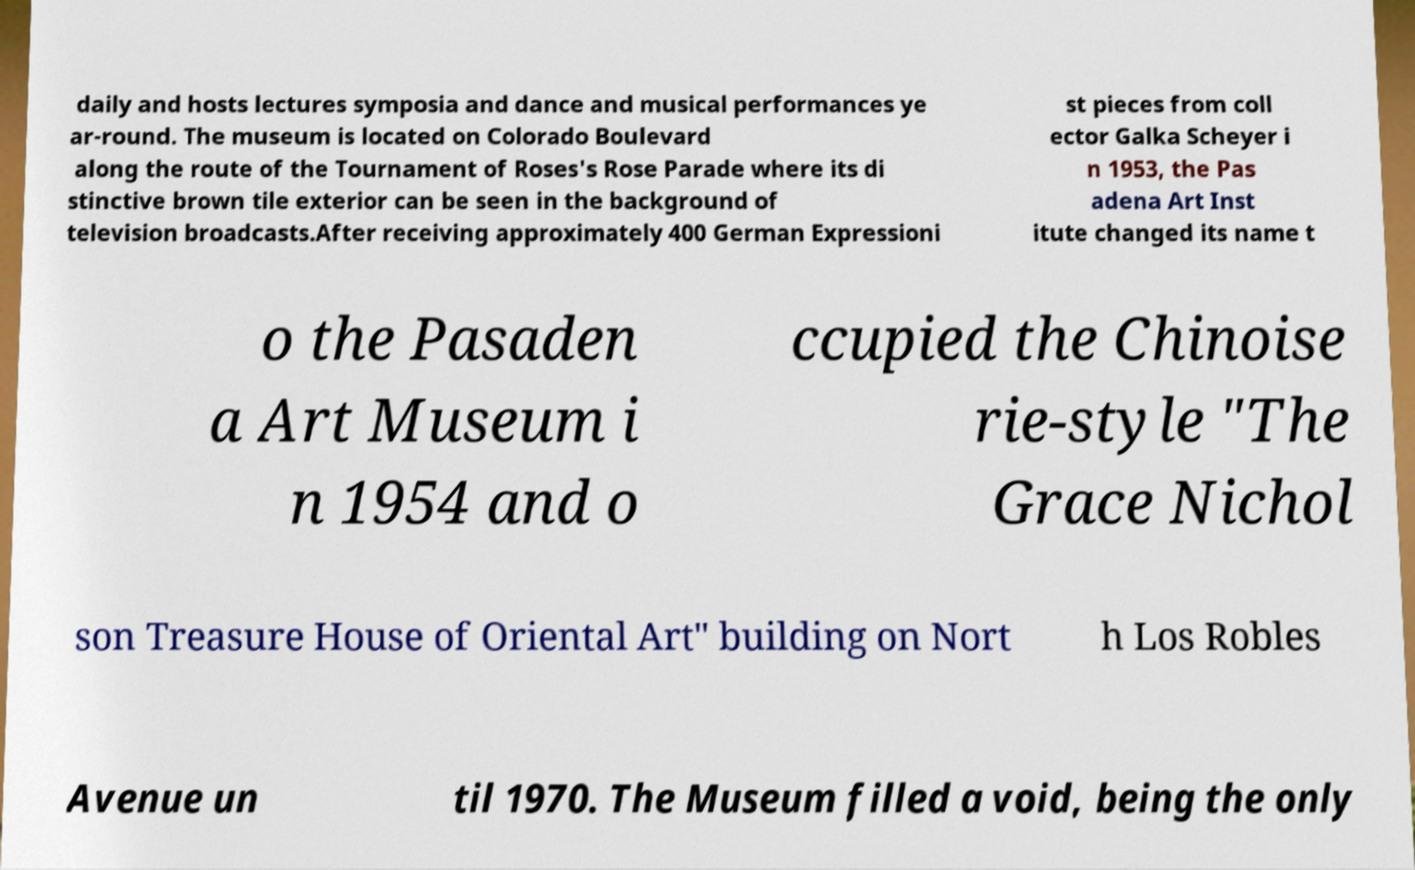Please read and relay the text visible in this image. What does it say? daily and hosts lectures symposia and dance and musical performances ye ar-round. The museum is located on Colorado Boulevard along the route of the Tournament of Roses's Rose Parade where its di stinctive brown tile exterior can be seen in the background of television broadcasts.After receiving approximately 400 German Expressioni st pieces from coll ector Galka Scheyer i n 1953, the Pas adena Art Inst itute changed its name t o the Pasaden a Art Museum i n 1954 and o ccupied the Chinoise rie-style "The Grace Nichol son Treasure House of Oriental Art" building on Nort h Los Robles Avenue un til 1970. The Museum filled a void, being the only 